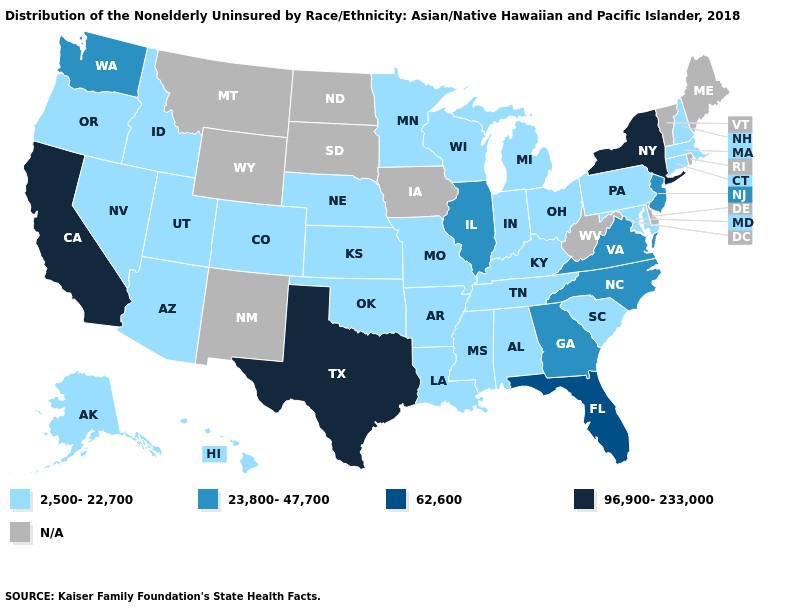What is the lowest value in states that border Washington?
Be succinct. 2,500-22,700. Which states have the highest value in the USA?
Answer briefly. California, New York, Texas. What is the value of Maryland?
Keep it brief. 2,500-22,700. Name the states that have a value in the range 62,600?
Keep it brief. Florida. Does Virginia have the highest value in the South?
Answer briefly. No. Name the states that have a value in the range 23,800-47,700?
Concise answer only. Georgia, Illinois, New Jersey, North Carolina, Virginia, Washington. Does Idaho have the highest value in the USA?
Give a very brief answer. No. Which states have the highest value in the USA?
Concise answer only. California, New York, Texas. What is the value of Illinois?
Write a very short answer. 23,800-47,700. What is the lowest value in the South?
Write a very short answer. 2,500-22,700. Does Illinois have the highest value in the MidWest?
Give a very brief answer. Yes. Name the states that have a value in the range N/A?
Keep it brief. Delaware, Iowa, Maine, Montana, New Mexico, North Dakota, Rhode Island, South Dakota, Vermont, West Virginia, Wyoming. 